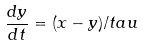Convert formula to latex. <formula><loc_0><loc_0><loc_500><loc_500>\frac { d y } { d t } = ( x - y ) / t a u</formula> 